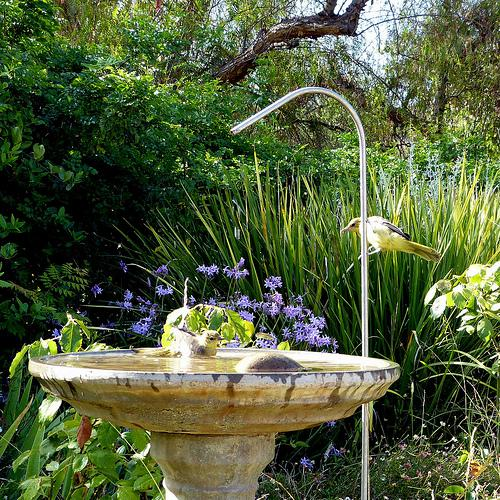Question: when was this picture taken?
Choices:
A. Moonlight.
B. Morning.
C. Daylight.
D. Night.
Answer with the letter. Answer: C Question: who captured this photo?
Choices:
A. The owner.
B. A photographer.
C. The groom.
D. The seller.
Answer with the letter. Answer: B Question: where was this picture taken?
Choices:
A. Near a haystack.
B. In a field.
C. Near the roses.
D. Back yard.
Answer with the letter. Answer: D Question: what is the object in the photo?
Choices:
A. A bird house.
B. A bird bath.
C. A bathing pool.
D. A tub.
Answer with the letter. Answer: B Question: why is there a bird perched close to the object?
Choices:
A. Bird house.
B. Bird feeder.
C. Bird nest.
D. Bird bath.
Answer with the letter. Answer: D 